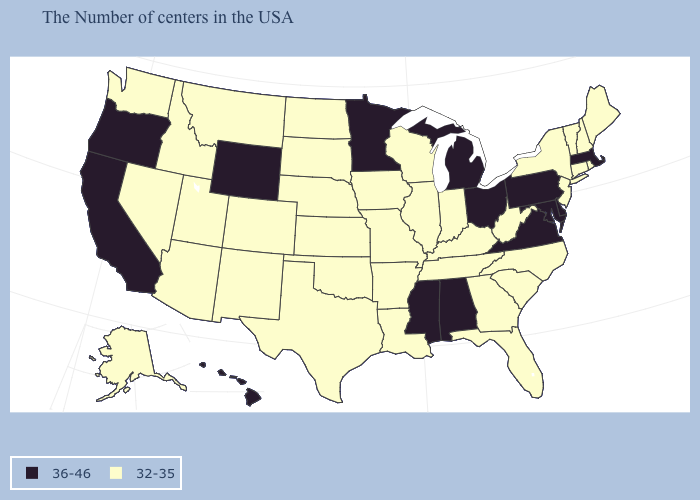Does North Dakota have the lowest value in the MidWest?
Short answer required. Yes. Name the states that have a value in the range 32-35?
Quick response, please. Maine, Rhode Island, New Hampshire, Vermont, Connecticut, New York, New Jersey, North Carolina, South Carolina, West Virginia, Florida, Georgia, Kentucky, Indiana, Tennessee, Wisconsin, Illinois, Louisiana, Missouri, Arkansas, Iowa, Kansas, Nebraska, Oklahoma, Texas, South Dakota, North Dakota, Colorado, New Mexico, Utah, Montana, Arizona, Idaho, Nevada, Washington, Alaska. How many symbols are there in the legend?
Quick response, please. 2. Name the states that have a value in the range 32-35?
Be succinct. Maine, Rhode Island, New Hampshire, Vermont, Connecticut, New York, New Jersey, North Carolina, South Carolina, West Virginia, Florida, Georgia, Kentucky, Indiana, Tennessee, Wisconsin, Illinois, Louisiana, Missouri, Arkansas, Iowa, Kansas, Nebraska, Oklahoma, Texas, South Dakota, North Dakota, Colorado, New Mexico, Utah, Montana, Arizona, Idaho, Nevada, Washington, Alaska. Name the states that have a value in the range 32-35?
Quick response, please. Maine, Rhode Island, New Hampshire, Vermont, Connecticut, New York, New Jersey, North Carolina, South Carolina, West Virginia, Florida, Georgia, Kentucky, Indiana, Tennessee, Wisconsin, Illinois, Louisiana, Missouri, Arkansas, Iowa, Kansas, Nebraska, Oklahoma, Texas, South Dakota, North Dakota, Colorado, New Mexico, Utah, Montana, Arizona, Idaho, Nevada, Washington, Alaska. How many symbols are there in the legend?
Be succinct. 2. Name the states that have a value in the range 36-46?
Be succinct. Massachusetts, Delaware, Maryland, Pennsylvania, Virginia, Ohio, Michigan, Alabama, Mississippi, Minnesota, Wyoming, California, Oregon, Hawaii. Among the states that border Ohio , does Michigan have the highest value?
Short answer required. Yes. Is the legend a continuous bar?
Quick response, please. No. Which states have the highest value in the USA?
Keep it brief. Massachusetts, Delaware, Maryland, Pennsylvania, Virginia, Ohio, Michigan, Alabama, Mississippi, Minnesota, Wyoming, California, Oregon, Hawaii. Which states have the lowest value in the Northeast?
Keep it brief. Maine, Rhode Island, New Hampshire, Vermont, Connecticut, New York, New Jersey. Which states have the lowest value in the South?
Give a very brief answer. North Carolina, South Carolina, West Virginia, Florida, Georgia, Kentucky, Tennessee, Louisiana, Arkansas, Oklahoma, Texas. What is the highest value in the Northeast ?
Be succinct. 36-46. Does North Dakota have the lowest value in the MidWest?
Write a very short answer. Yes. Name the states that have a value in the range 36-46?
Concise answer only. Massachusetts, Delaware, Maryland, Pennsylvania, Virginia, Ohio, Michigan, Alabama, Mississippi, Minnesota, Wyoming, California, Oregon, Hawaii. 